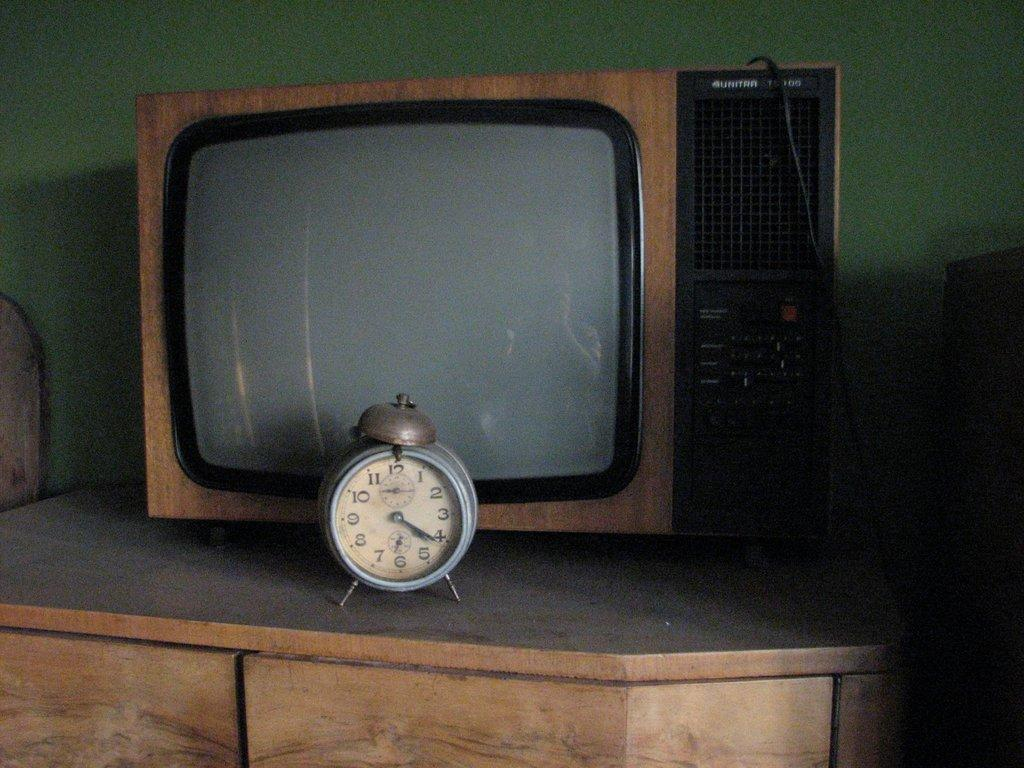<image>
Summarize the visual content of the image. An old school clock reads 4:21 and sits in front of a TV. 